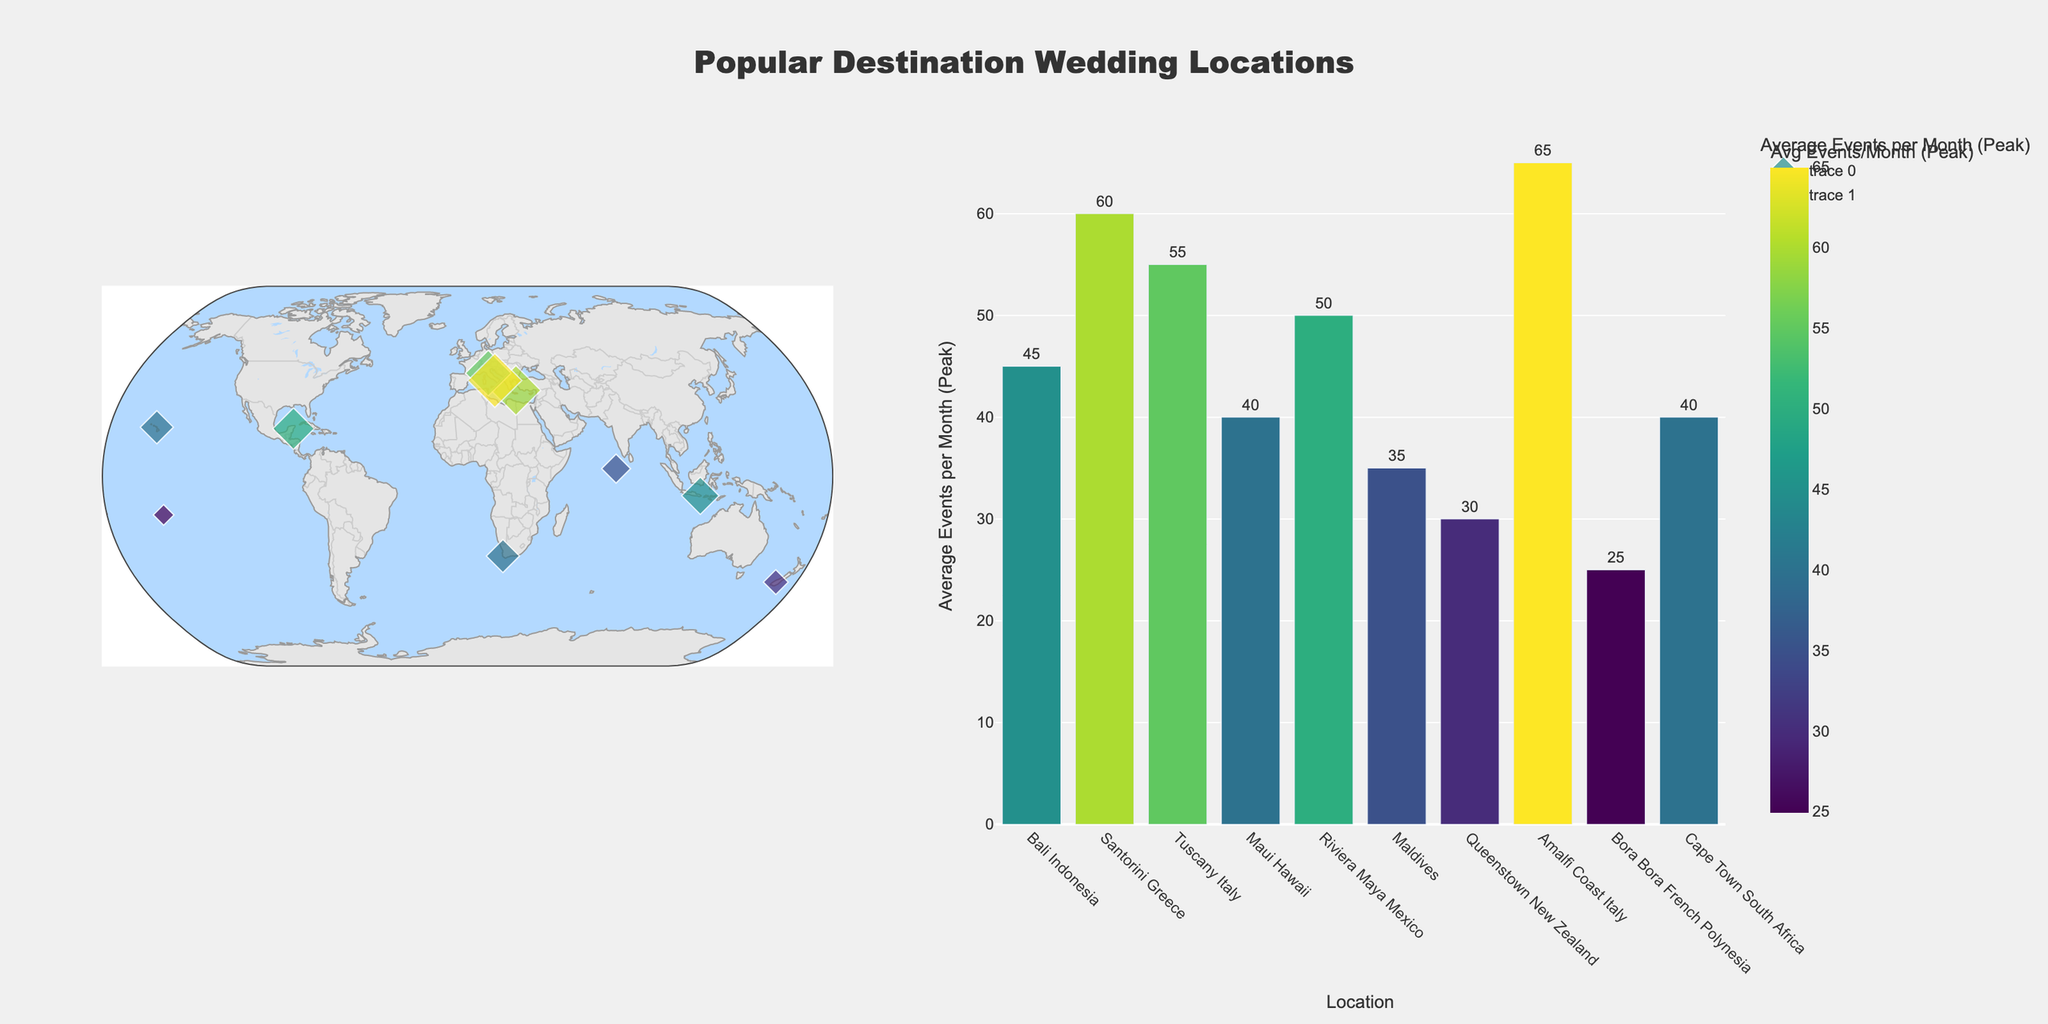what is the title of the figure? The title of the figure is displayed at the top center.
Answer: Popular Destination Wedding Locations How many locations are shown on the map? Count the number of markers on the scatter geo plot or the number of bars in the bar chart.
Answer: 10 Which location has the highest average events per month during the peak season? Look at the bar chart and identify the tallest bar, or check the color scale for the darkest color.
Answer: Amalfi Coast Italy Which location has the lowest average events per month during the peak season? Look at the bar chart and identify the shortest bar, or check the color scale for the lightest color.
Answer: Bora Bora French Polynesia What are the peak seasons for Santorini, Greece, and Tuscany, Italy? Look at the scatter geo plot/map and find the information in the pop-up text for each location or refer to the provided data.
Answer: May-September for Santorini, May-October for Tuscany Which location has the most balanced average events per month given the peak season duration? Determine the average events per month and the duration of the peak season for each location, then identify the one with the peak season encompassing the highest portion of the year (5 or 6 months). Divide the average events by the duration of the peak season.
Answer: Tuscany Italy What is the combined average number of events per month during the peak season for Maui, Hawaii, and Cape Town, South Africa? Add the average events per month during the peak season for both locations: 40 (Maui) + 40 (Cape Town).
Answer: 80 During which months is Bali off-peak for weddings? Look at the scatter geo plot/map and find the information in the pop-up text for Bali or refer to the provided data.
Answer: January-March Which two locations have a peak season that extends from December to April? Look at the scatter geo plot/map or the provided data to compare the peak seasons of all locations.
Answer: Riviera Maya Mexico and Maldives How does the peak average number of events per month in Maui, Hawaii, compare to Queenstown, New Zealand? Look at the bar chart and compare the height and color intensity of the bars for Maui, Hawaii, and Queenstown, New Zealand. Maui has 40 while Queenstown has 30.
Answer: Maui has 10 more average events per month 